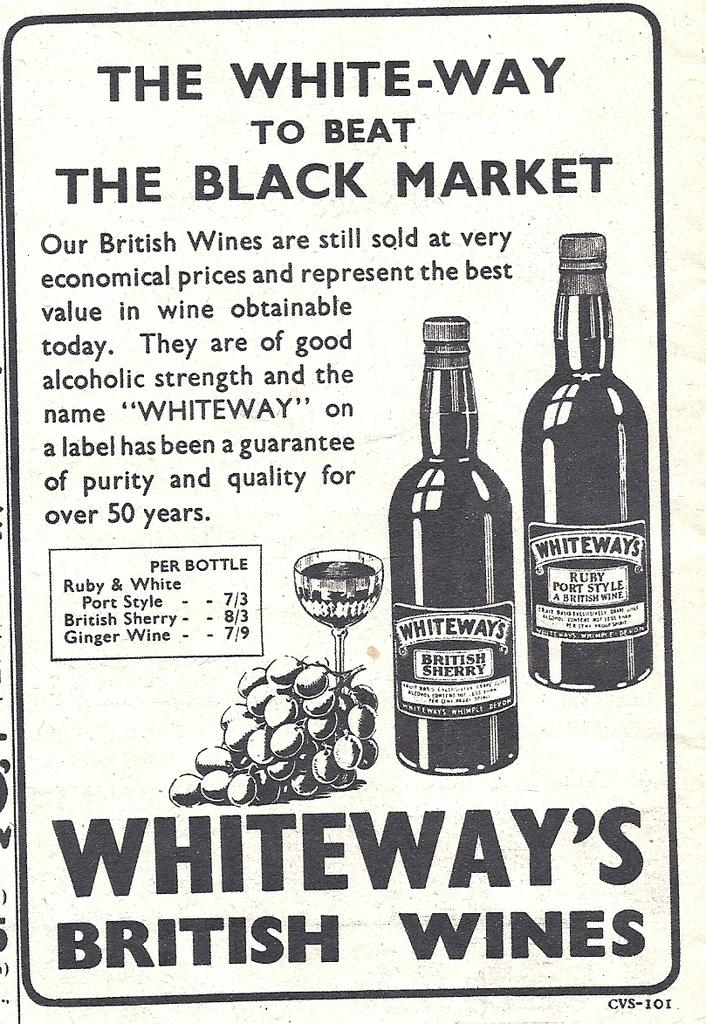Provide a one-sentence caption for the provided image. A poster in white and black advertising Whiteway's British Wines. 